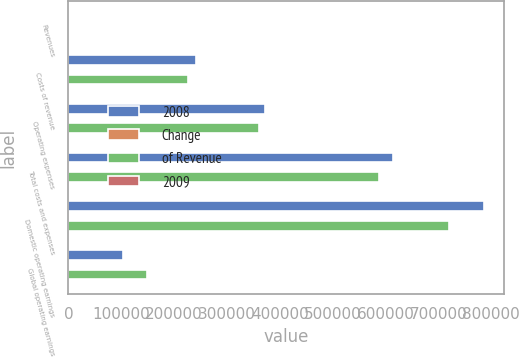Convert chart to OTSL. <chart><loc_0><loc_0><loc_500><loc_500><stacked_bar_chart><ecel><fcel>Revenues<fcel>Costs of revenue<fcel>Operating expenses<fcel>Total costs and expenses<fcel>Domestic operating earnings<fcel>Global operating earnings<nl><fcel>2008<fcel>78<fcel>240847<fcel>372370<fcel>613217<fcel>785498<fcel>102542<nl><fcel>Change<fcel>100<fcel>17<fcel>27<fcel>44<fcel>56<fcel>38<nl><fcel>of Revenue<fcel>78<fcel>225955<fcel>361213<fcel>587168<fcel>720342<fcel>147681<nl><fcel>2009<fcel>7<fcel>7<fcel>3<fcel>4<fcel>9<fcel>31<nl></chart> 